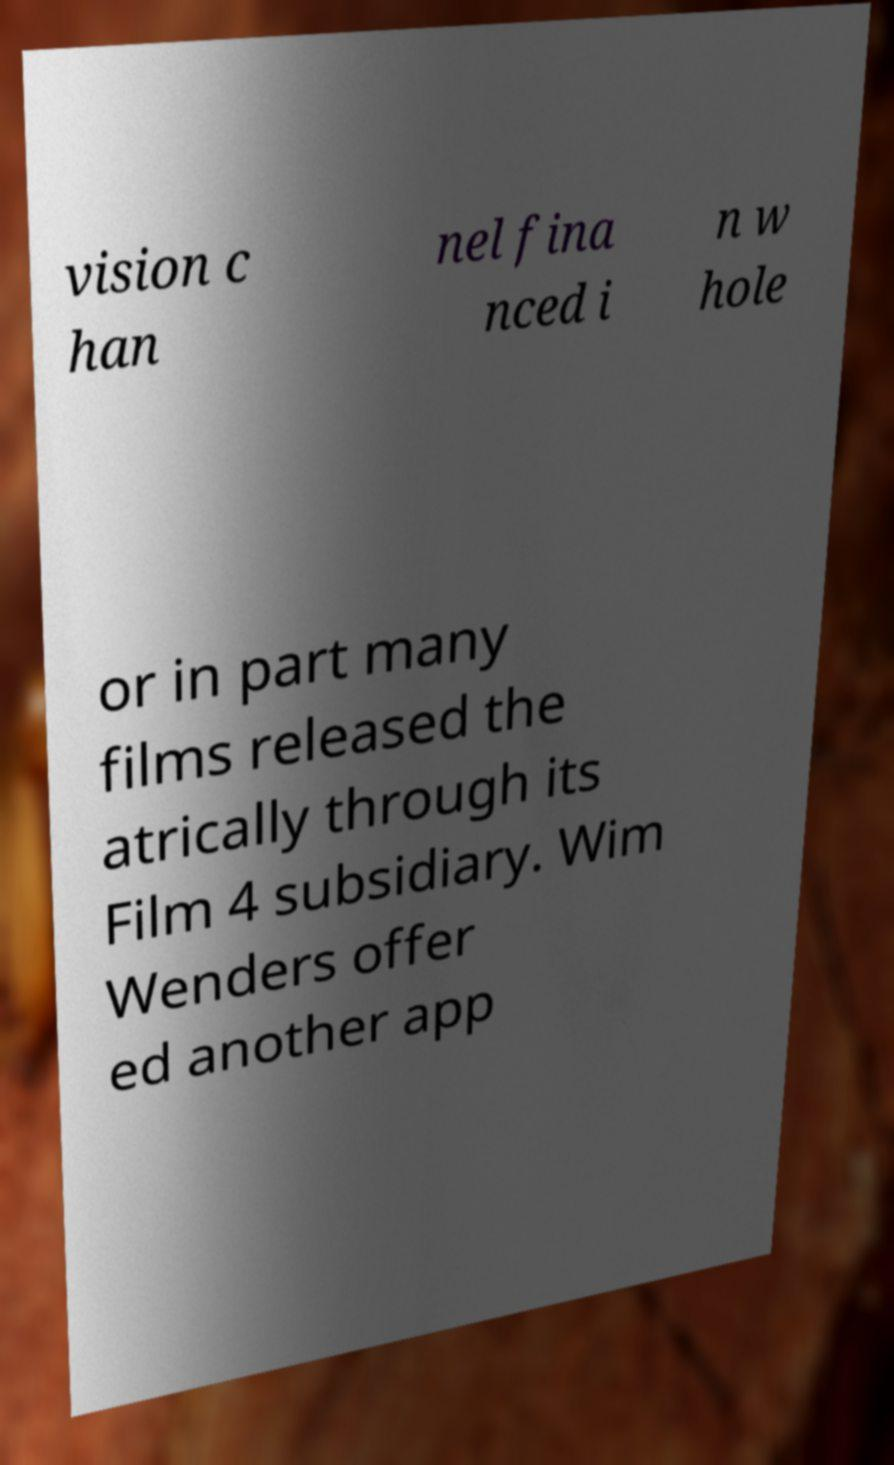Could you extract and type out the text from this image? vision c han nel fina nced i n w hole or in part many films released the atrically through its Film 4 subsidiary. Wim Wenders offer ed another app 